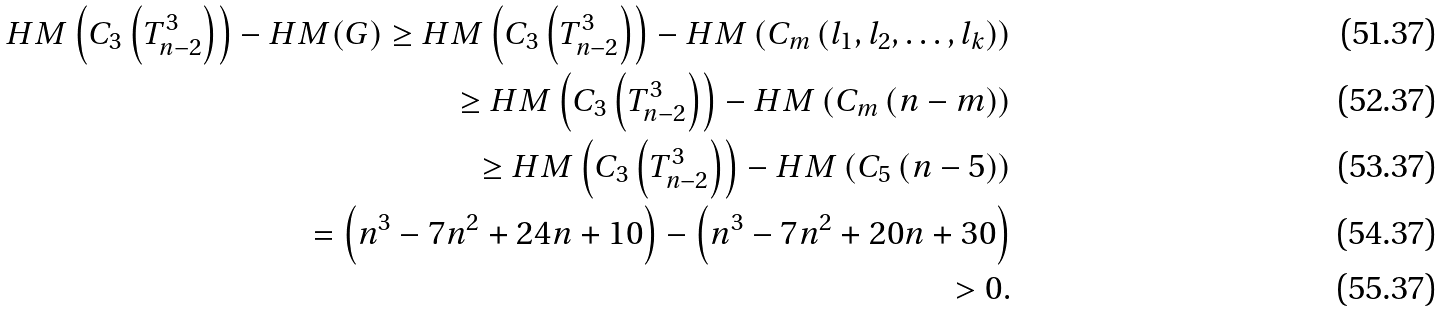Convert formula to latex. <formula><loc_0><loc_0><loc_500><loc_500>H M \left ( C _ { 3 } \left ( T ^ { 3 } _ { n - 2 } \right ) \right ) - H M ( G ) \geq H M \left ( C _ { 3 } \left ( T ^ { 3 } _ { n - 2 } \right ) \right ) - H M \left ( C _ { m } \left ( l _ { 1 } , l _ { 2 } , \dots , l _ { k } \right ) \right ) \\ \geq H M \left ( C _ { 3 } \left ( T ^ { 3 } _ { n - 2 } \right ) \right ) - H M \left ( C _ { m } \left ( n - m \right ) \right ) \\ \geq H M \left ( C _ { 3 } \left ( T ^ { 3 } _ { n - 2 } \right ) \right ) - H M \left ( C _ { 5 } \left ( n - 5 \right ) \right ) \\ = \left ( n ^ { 3 } - 7 n ^ { 2 } + 2 4 n + 1 0 \right ) - \left ( n ^ { 3 } - 7 n ^ { 2 } + 2 0 n + 3 0 \right ) \\ > 0 .</formula> 